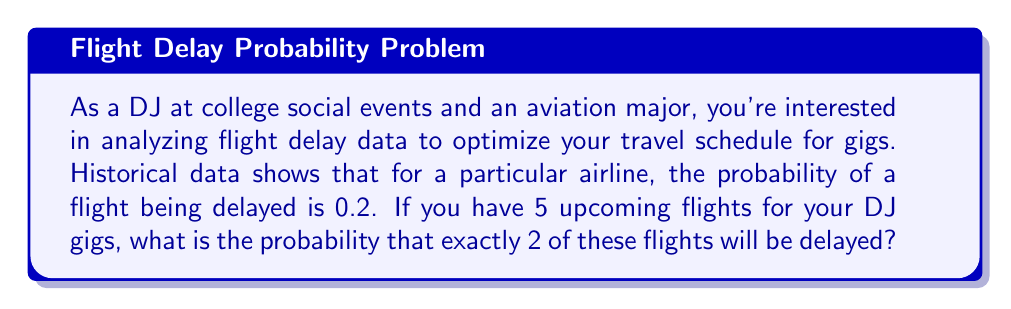Can you answer this question? To solve this problem, we'll use the binomial probability distribution, as we're dealing with a fixed number of independent trials (flights) with two possible outcomes (delayed or not delayed) and a constant probability of success (delay).

The binomial probability formula is:

$$P(X = k) = \binom{n}{k} p^k (1-p)^{n-k}$$

Where:
$n$ = number of trials (flights)
$k$ = number of successes (delays)
$p$ = probability of success (delay) on each trial

Given:
$n = 5$ (total number of flights)
$k = 2$ (exactly 2 flights delayed)
$p = 0.2$ (probability of a flight being delayed)

Step 1: Calculate the binomial coefficient
$$\binom{5}{2} = \frac{5!}{2!(5-2)!} = \frac{5 \cdot 4}{2 \cdot 1} = 10$$

Step 2: Calculate $p^k$
$$0.2^2 = 0.04$$

Step 3: Calculate $(1-p)^{n-k}$
$$(1-0.2)^{5-2} = 0.8^3 = 0.512$$

Step 4: Multiply the results from steps 1, 2, and 3
$$10 \cdot 0.04 \cdot 0.512 = 0.2048$$

Therefore, the probability of exactly 2 out of 5 flights being delayed is 0.2048 or 20.48%.
Answer: 0.2048 or 20.48% 